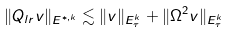Convert formula to latex. <formula><loc_0><loc_0><loc_500><loc_500>\| Q _ { l r } v \| _ { \L E ^ { * , k } } \lesssim \| v \| _ { \L E _ { \tau } ^ { k } } + \| \Omega ^ { 2 } v \| _ { \L E _ { \tau } ^ { k } }</formula> 